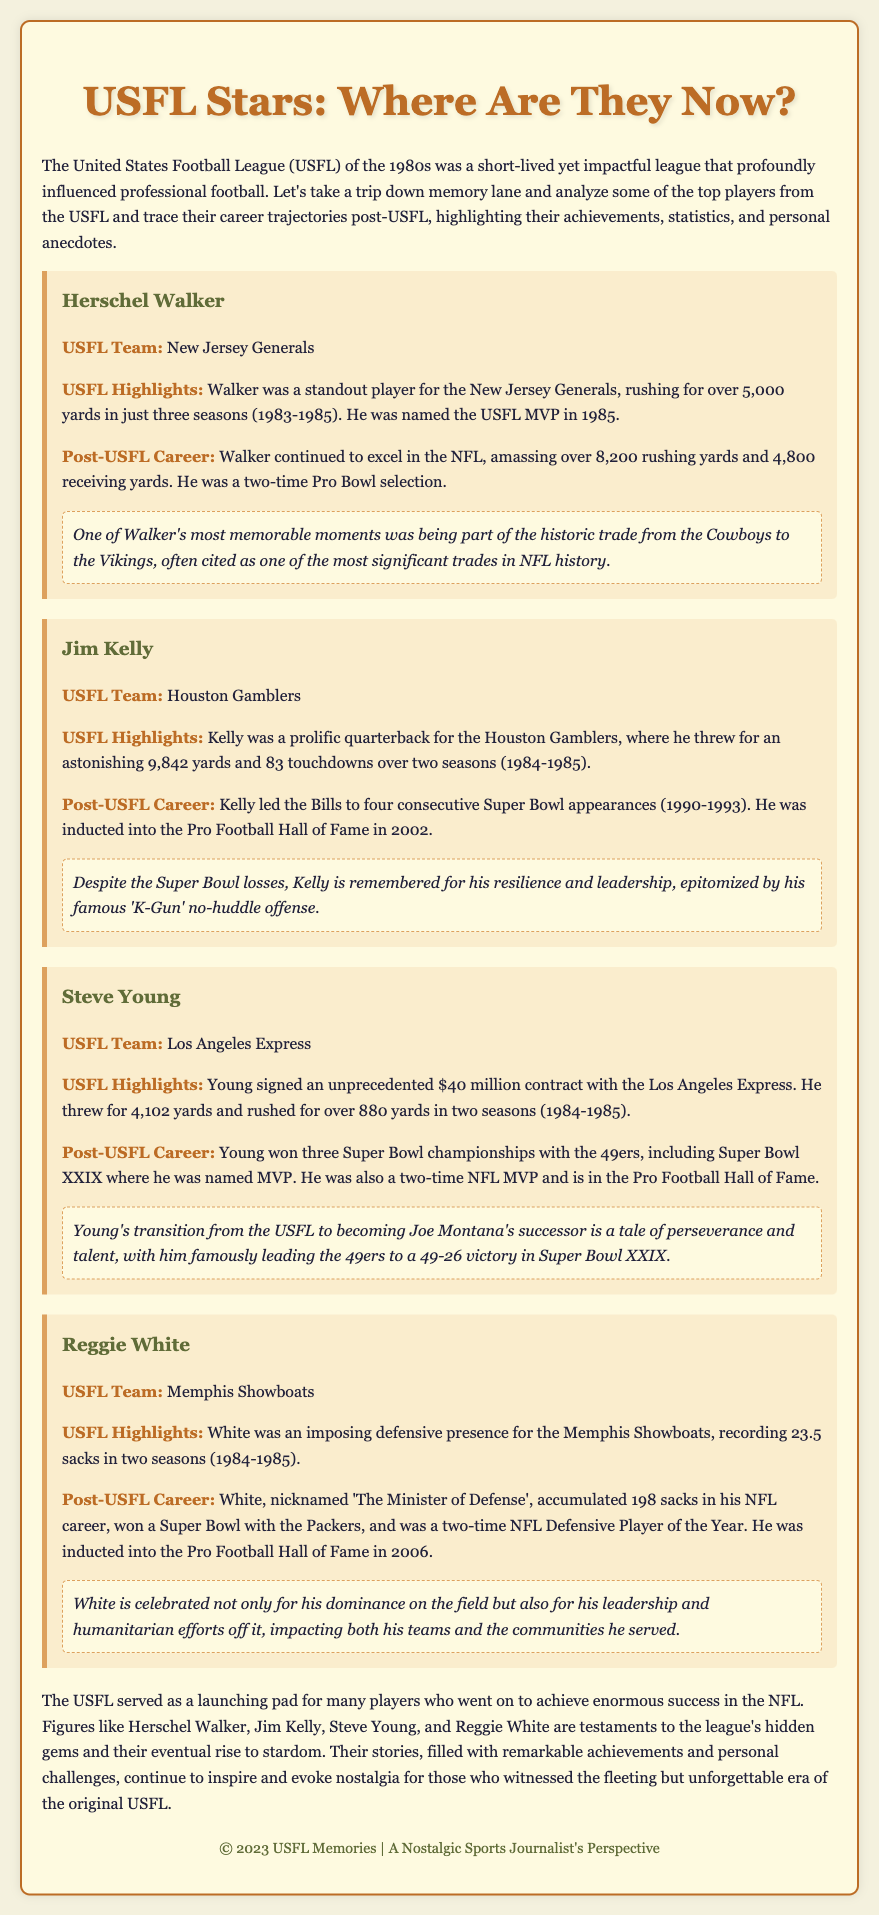What team did Herschel Walker play for in the USFL? Herschel Walker played for the New Jersey Generals in the USFL.
Answer: New Jersey Generals How many rushing yards did Jim Kelly throw for in the USFL? Jim Kelly threw for 9,842 yards in the USFL.
Answer: 9,842 yards What significant contract did Steve Young sign with the Los Angeles Express? Steve Young signed a $40 million contract with the Los Angeles Express.
Answer: $40 million How many Super Bowls did Reggie White win in his career? Reggie White won 1 Super Bowl during his NFL career.
Answer: 1 What year was Jim Kelly inducted into the Pro Football Hall of Fame? Jim Kelly was inducted into the Pro Football Hall of Fame in 2002.
Answer: 2002 Which player was known as 'The Minister of Defense'? Reggie White was nicknamed 'The Minister of Defense'.
Answer: Reggie White How many Pro Bowl selections did Herschel Walker achieve? Herschel Walker was a two-time Pro Bowl selection.
Answer: two-time What theme connects the players mentioned in the document? The players mentioned all had remarkable achievements post-USFL.
Answer: Remarkable achievements What term is used to describe Jim Kelly's offensive style? Jim Kelly's offensive style is known as the 'K-Gun'.
Answer: 'K-Gun' 